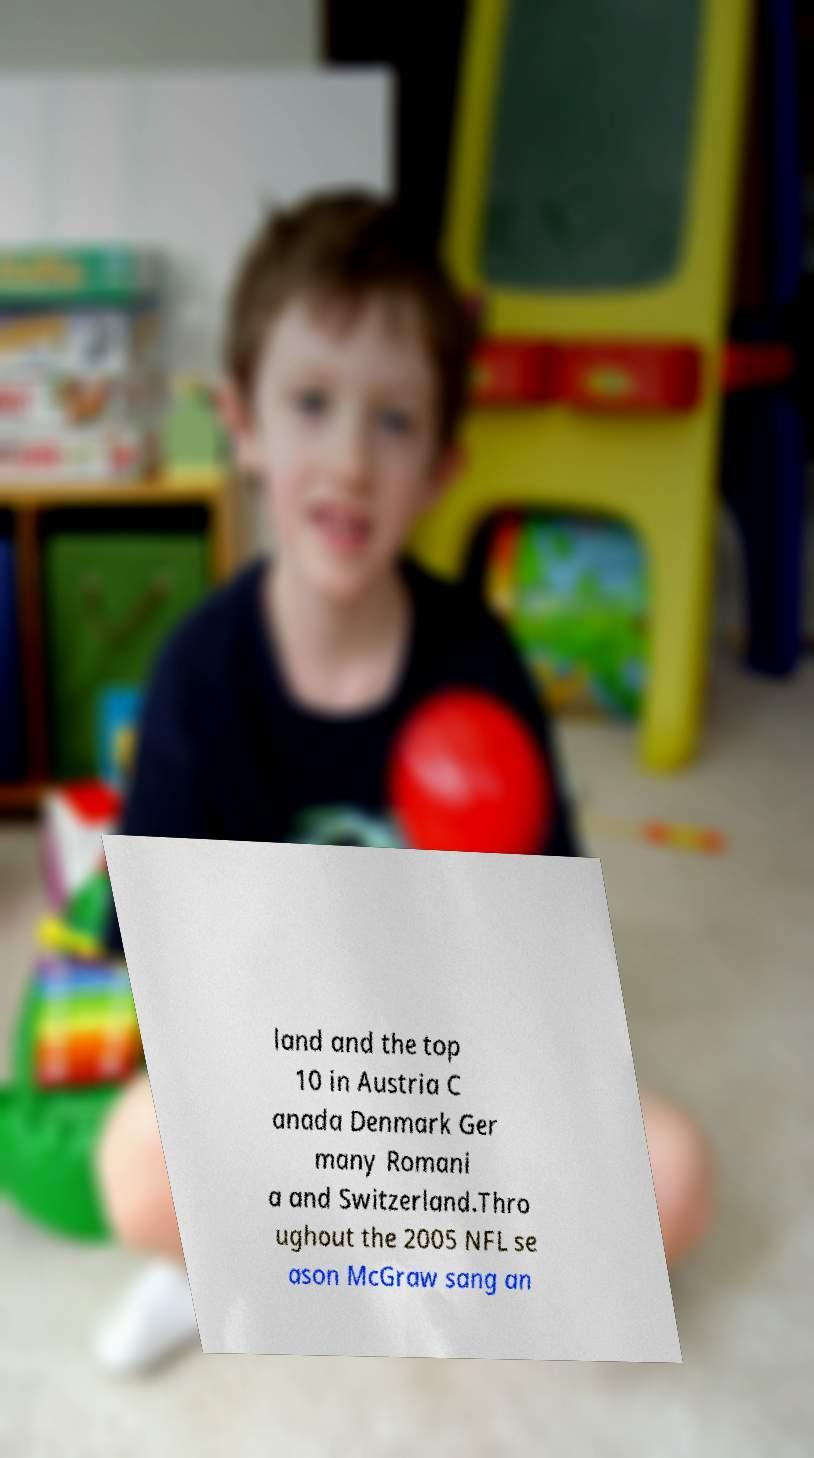Please identify and transcribe the text found in this image. land and the top 10 in Austria C anada Denmark Ger many Romani a and Switzerland.Thro ughout the 2005 NFL se ason McGraw sang an 